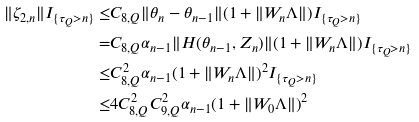Convert formula to latex. <formula><loc_0><loc_0><loc_500><loc_500>\| \zeta _ { 2 , n } \| I _ { \{ \tau _ { Q } > n \} } \leq & C _ { 8 , Q } \| \theta _ { n } - \theta _ { n - 1 } \| ( 1 + \| W _ { n } \Lambda \| ) I _ { \{ \tau _ { Q } > n \} } \\ = & C _ { 8 , Q } \alpha _ { n - 1 } \| H ( \theta _ { n - 1 } , Z _ { n } ) \| ( 1 + \| W _ { n } \Lambda \| ) I _ { \{ \tau _ { Q } > n \} } \\ \leq & C _ { 8 , Q } ^ { 2 } \alpha _ { n - 1 } ( 1 + \| W _ { n } \Lambda \| ) ^ { 2 } I _ { \{ \tau _ { Q } > n \} } \\ \leq & 4 C _ { 8 , Q } ^ { 2 } C _ { 9 , Q } ^ { 2 } \alpha _ { n - 1 } ( 1 + \| W _ { 0 } \Lambda \| ) ^ { 2 }</formula> 